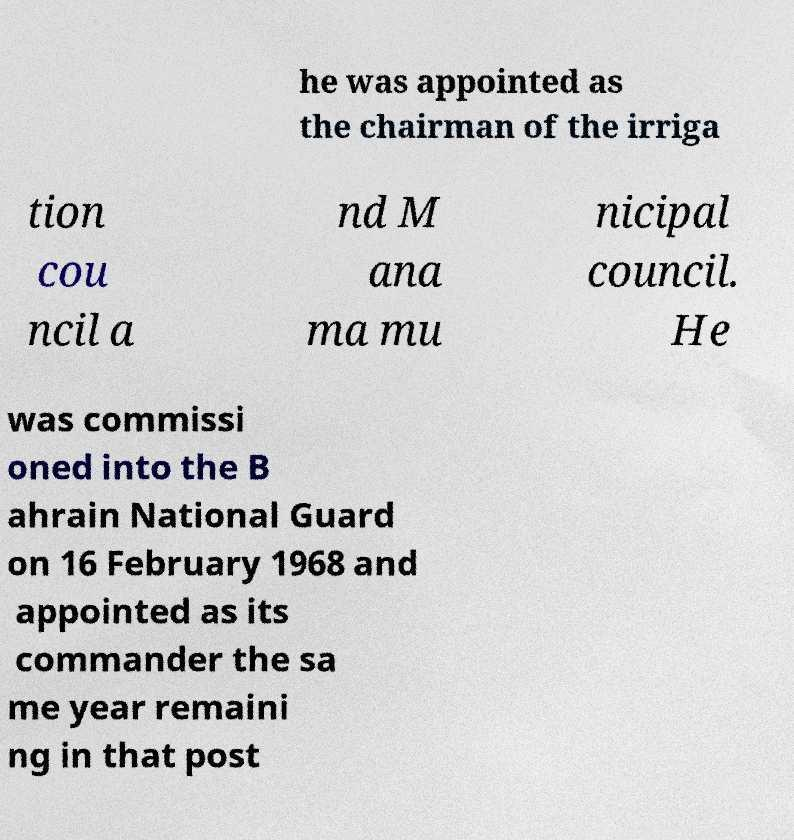Could you assist in decoding the text presented in this image and type it out clearly? he was appointed as the chairman of the irriga tion cou ncil a nd M ana ma mu nicipal council. He was commissi oned into the B ahrain National Guard on 16 February 1968 and appointed as its commander the sa me year remaini ng in that post 